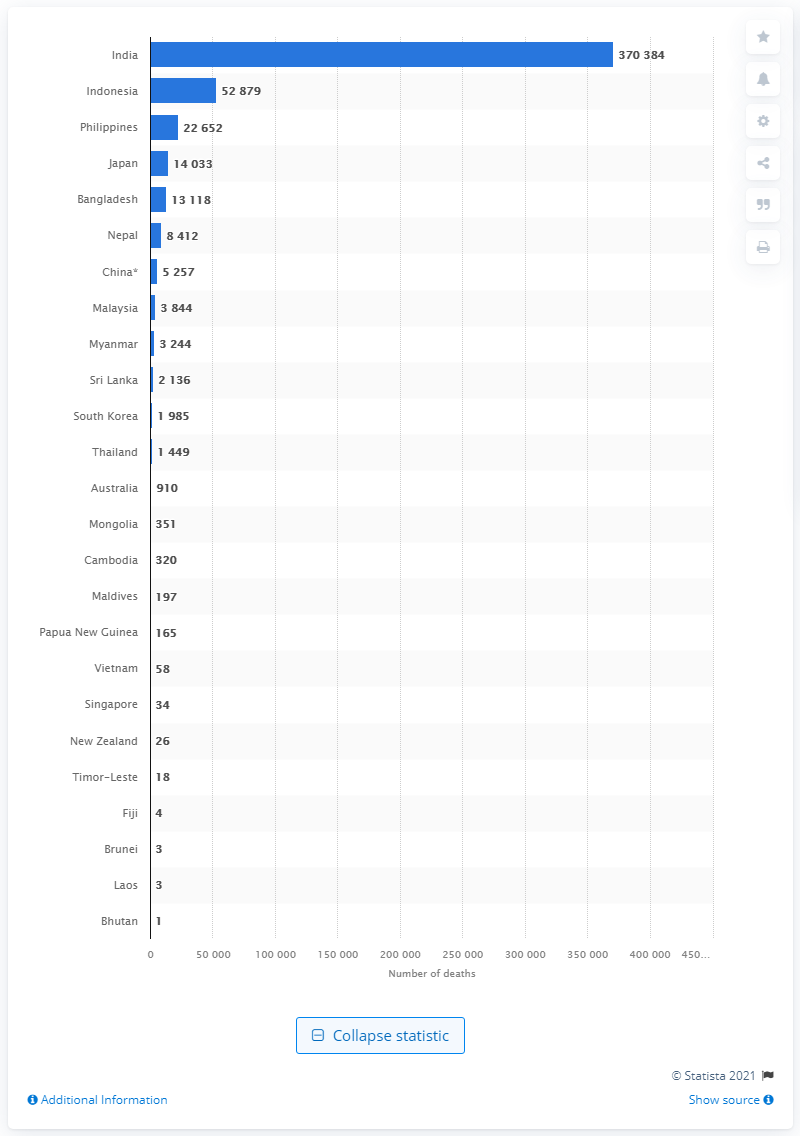Point out several critical features in this image. India had the highest number of confirmed deaths due to the outbreak of the novel coronavirus in the Asia Pacific region. Indonesia was the country with the second highest number of coronavirus deaths in the Asia Pacific region. As of June 13, 2021, a total of 370,384 deaths in India were recorded due to the novel coronavirus. On June 13, 2021, Bhutan was the only country to report a death due to COVID-19. 